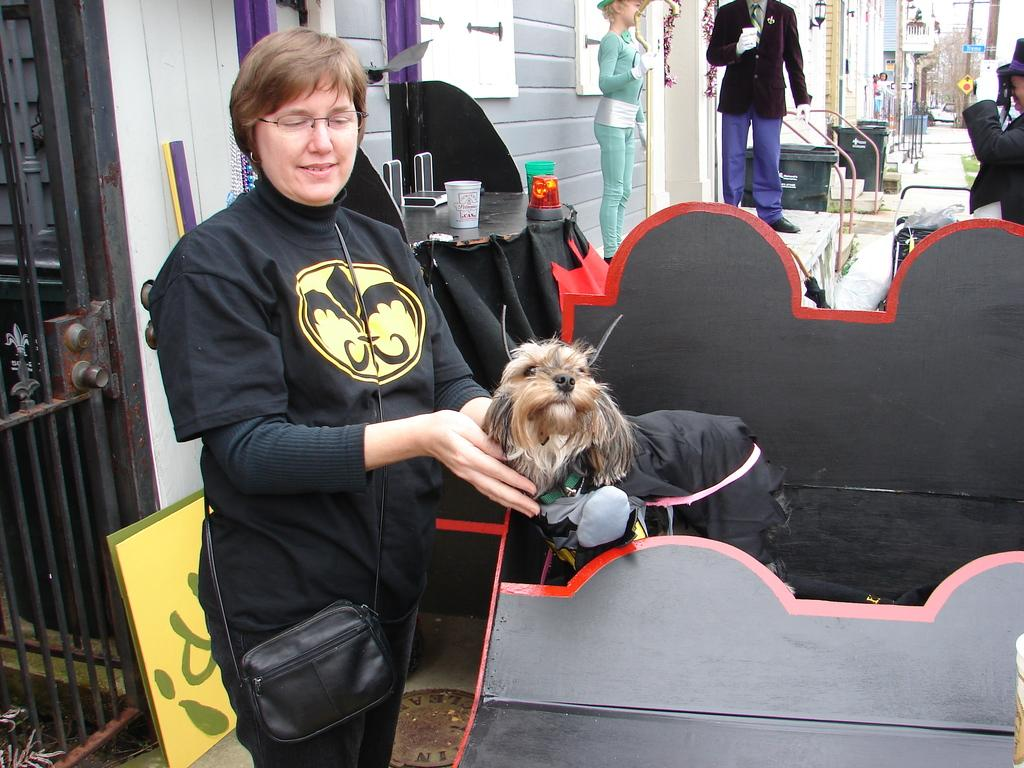What is the woman doing in the image? The woman is standing and smiling in the image. What other living creature is present in the image? There is a dog in the image. What object can be seen near the woman? There are glasses in the image. What type of inanimate figures are in the image? There are mannequins in the image. What is the background of the image composed of? There is a wall, buildings, and trees visible in the background of the image. How many women are providing care to the animals in the image? There is no indication of any women providing care to animals in the image, as it only features a woman standing and smiling, a dog, and mannequins. 